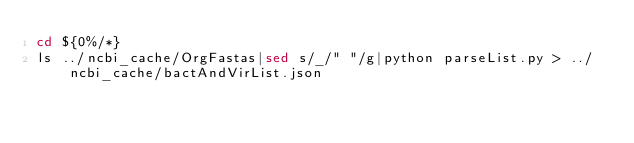<code> <loc_0><loc_0><loc_500><loc_500><_Bash_>cd ${0%/*}
ls ../ncbi_cache/OrgFastas|sed s/_/" "/g|python parseList.py > ../ncbi_cache/bactAndVirList.json

</code> 